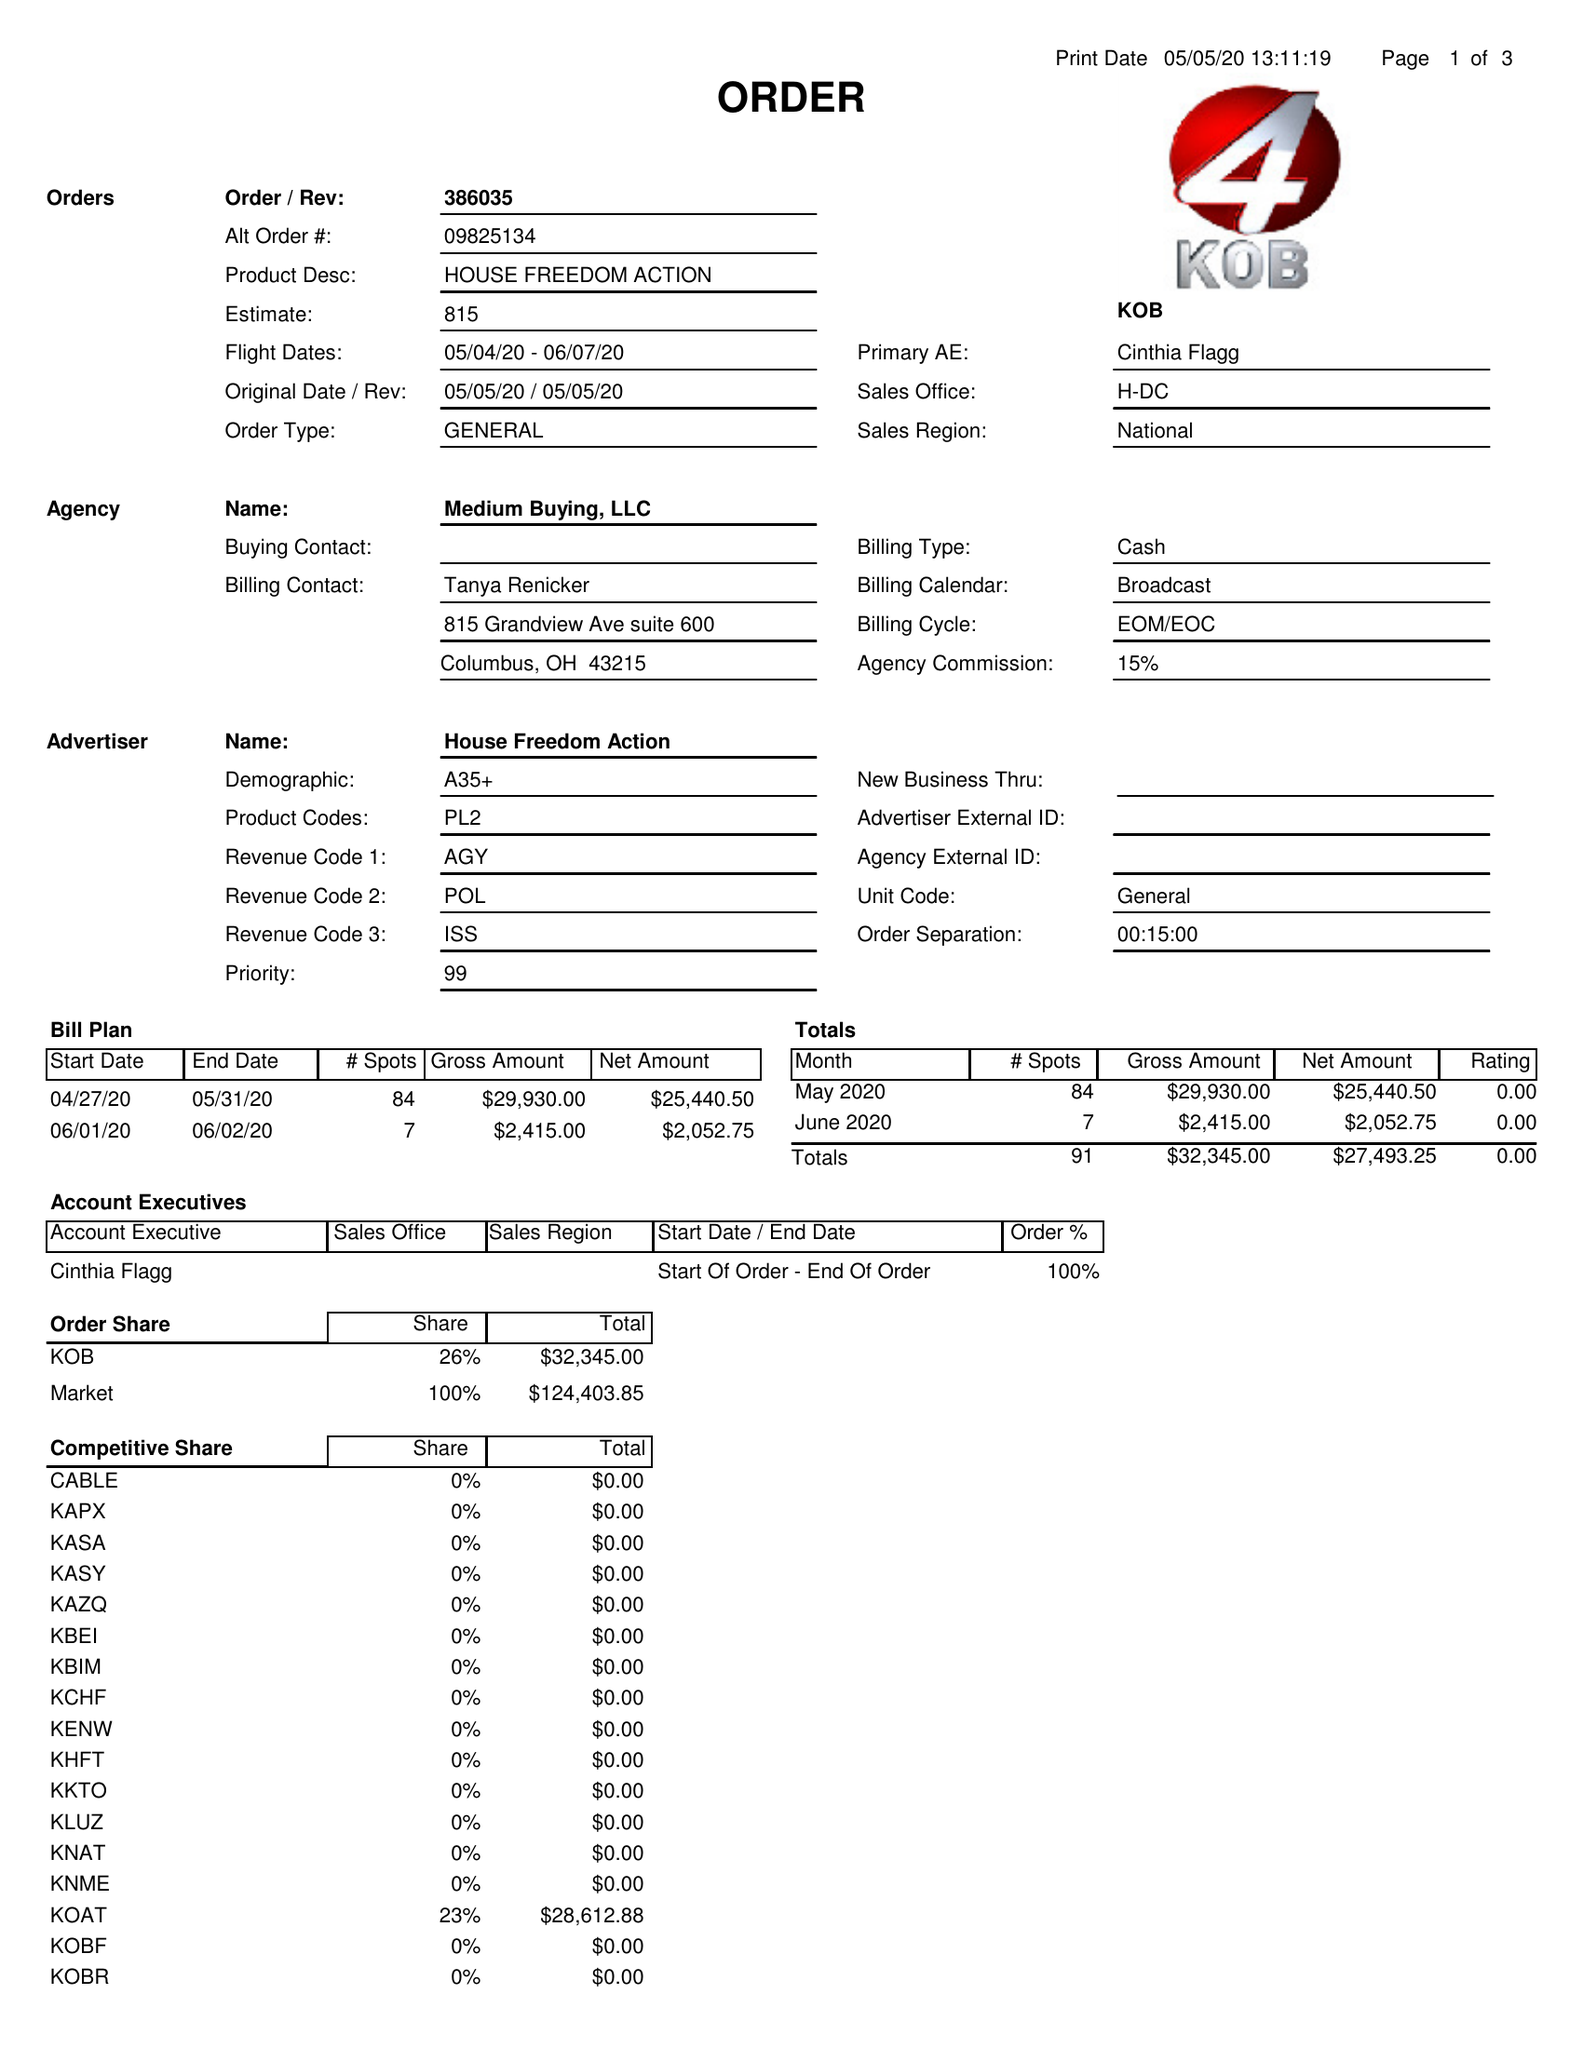What is the value for the gross_amount?
Answer the question using a single word or phrase. 32345.00 